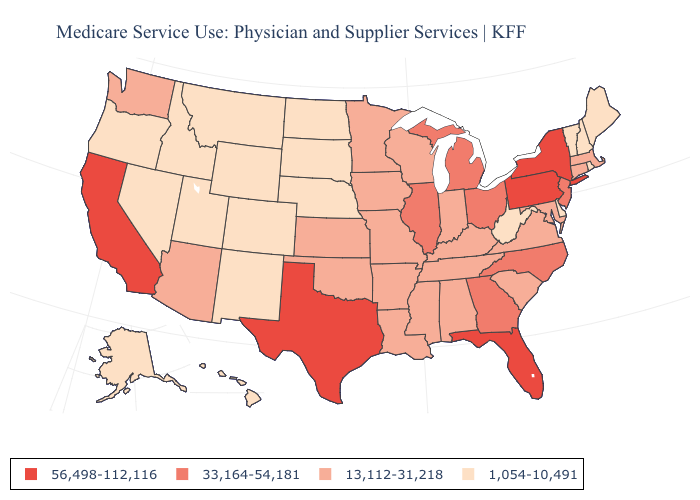Does Massachusetts have a lower value than Florida?
Keep it brief. Yes. Does Oklahoma have a higher value than Pennsylvania?
Quick response, please. No. What is the value of Arizona?
Write a very short answer. 13,112-31,218. Name the states that have a value in the range 56,498-112,116?
Be succinct. California, Florida, New York, Pennsylvania, Texas. Does Alabama have the highest value in the South?
Quick response, please. No. How many symbols are there in the legend?
Be succinct. 4. What is the value of Vermont?
Keep it brief. 1,054-10,491. Name the states that have a value in the range 13,112-31,218?
Short answer required. Alabama, Arizona, Arkansas, Connecticut, Indiana, Iowa, Kansas, Kentucky, Louisiana, Maryland, Massachusetts, Minnesota, Mississippi, Missouri, Oklahoma, South Carolina, Tennessee, Virginia, Washington, Wisconsin. Name the states that have a value in the range 1,054-10,491?
Concise answer only. Alaska, Colorado, Delaware, Hawaii, Idaho, Maine, Montana, Nebraska, Nevada, New Hampshire, New Mexico, North Dakota, Oregon, Rhode Island, South Dakota, Utah, Vermont, West Virginia, Wyoming. Does North Dakota have the same value as Alaska?
Concise answer only. Yes. Does Idaho have the highest value in the West?
Give a very brief answer. No. Does California have the highest value in the West?
Keep it brief. Yes. Name the states that have a value in the range 1,054-10,491?
Concise answer only. Alaska, Colorado, Delaware, Hawaii, Idaho, Maine, Montana, Nebraska, Nevada, New Hampshire, New Mexico, North Dakota, Oregon, Rhode Island, South Dakota, Utah, Vermont, West Virginia, Wyoming. Does the first symbol in the legend represent the smallest category?
Give a very brief answer. No. 